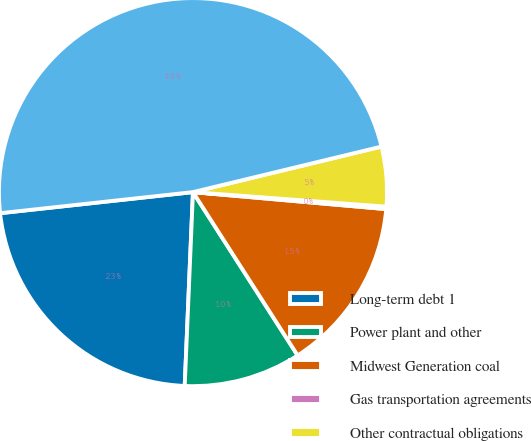Convert chart to OTSL. <chart><loc_0><loc_0><loc_500><loc_500><pie_chart><fcel>Long-term debt 1<fcel>Power plant and other<fcel>Midwest Generation coal<fcel>Gas transportation agreements<fcel>Other contractual obligations<fcel>Total Contractual Obligations<nl><fcel>22.59%<fcel>9.75%<fcel>14.53%<fcel>0.2%<fcel>4.97%<fcel>47.96%<nl></chart> 